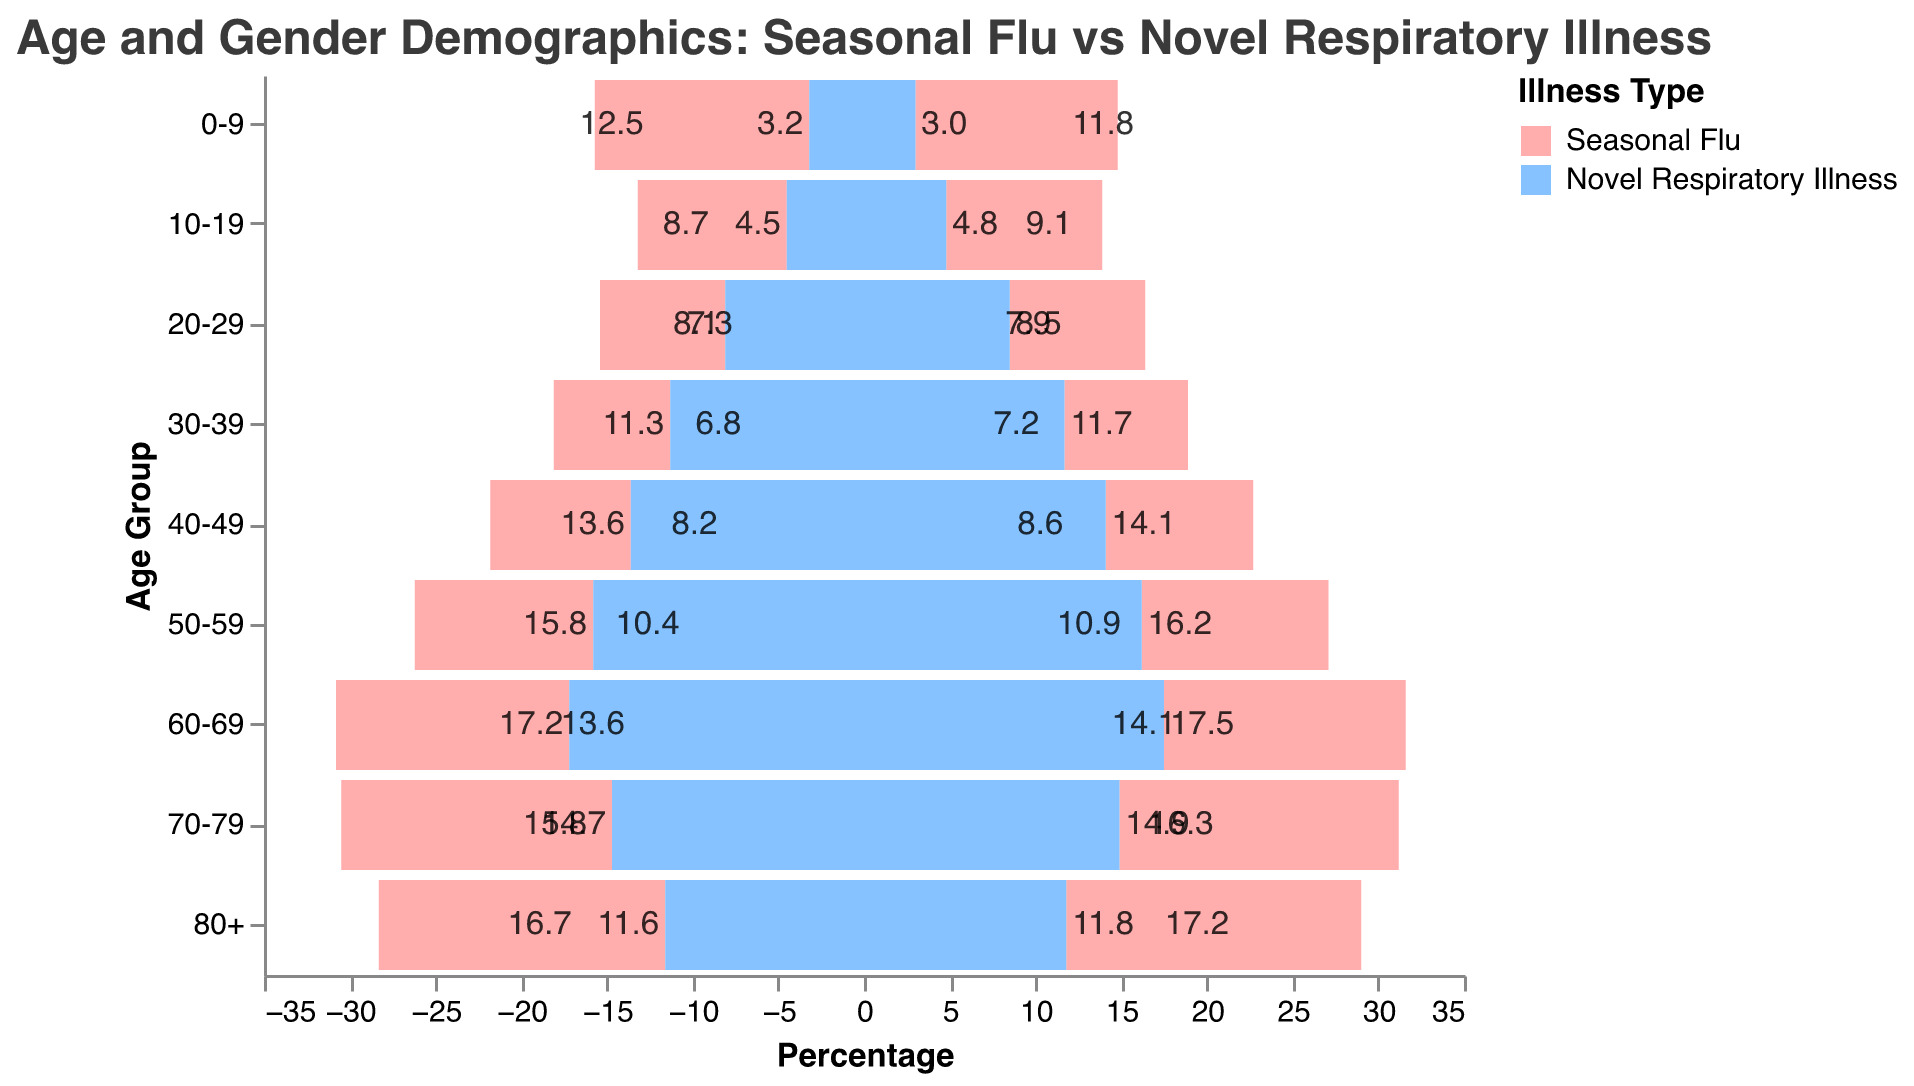What is the title of the chart? The title is usually located at the top of the chart and provides a summary of what the chart depicts. In this case, it gives an overview of the demographics being compared.
Answer: Age and Gender Demographics: Seasonal Flu vs Novel Respiratory Illness Which age group has the highest percentage of females affected by the seasonal flu? Look at the female bars for the seasonal flu and identify the age group with the longest bar.
Answer: 80+ How does the percentage of males aged 30-39 affected by the novel respiratory illness compare to the percentage affected by the seasonal flu in the same age group? Compare the lengths of the bars representing males aged 30-39 for both illnesses; the bars going left for the novel respiratory illness and right for the seasonal flu.
Answer: Novel respiratory illness is higher In the 60-69 age group, what is the combined percentage of males and females affected by the novel respiratory illness? Add the percentages of males and females for the novel respiratory illness in the 60-69 age group.
Answer: 34.7 Which illness has a higher percentage of males in the 70-79 age group? Compare the lengths of the bars representing males in the 70-79 age group for both illnesses.
Answer: Seasonal Flu Are females in the 50-59 age group more affected by the seasonal flu or the novel respiratory illness? Compare the percentages (bar lengths) for females aged 50-59 for both illnesses.
Answer: Novel Respiratory Illness Which gender has a higher percentage of individuals affected by the novel respiratory illness in the 20-29 age group? Compare the bars for males and females aged 20-29 for the novel respiratory illness.
Answer: Female What can you infer about the impact of the novel respiratory illness on older age groups (70+) compared to the seasonal flu? Analyze the bars for the 70-79 age group and 80+ age group for both illnesses to see how the percentages differ.
Answer: Novel respiratory illness impacts the 70-79 age group less but the 80+ age group more than seasonal flu 